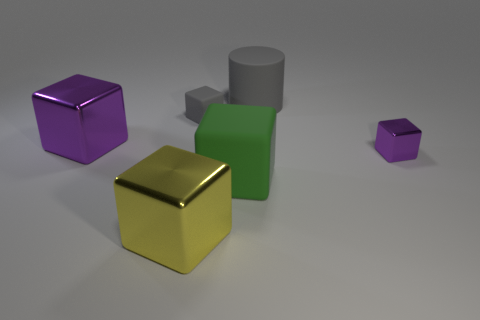Subtract all gray matte blocks. How many blocks are left? 4 Subtract all gray cubes. How many cubes are left? 4 Add 1 big cubes. How many objects exist? 7 Subtract all cyan cubes. Subtract all red balls. How many cubes are left? 5 Subtract all cylinders. How many objects are left? 5 Add 4 gray matte cylinders. How many gray matte cylinders are left? 5 Add 1 large blue objects. How many large blue objects exist? 1 Subtract 1 yellow cubes. How many objects are left? 5 Subtract all cyan shiny balls. Subtract all purple things. How many objects are left? 4 